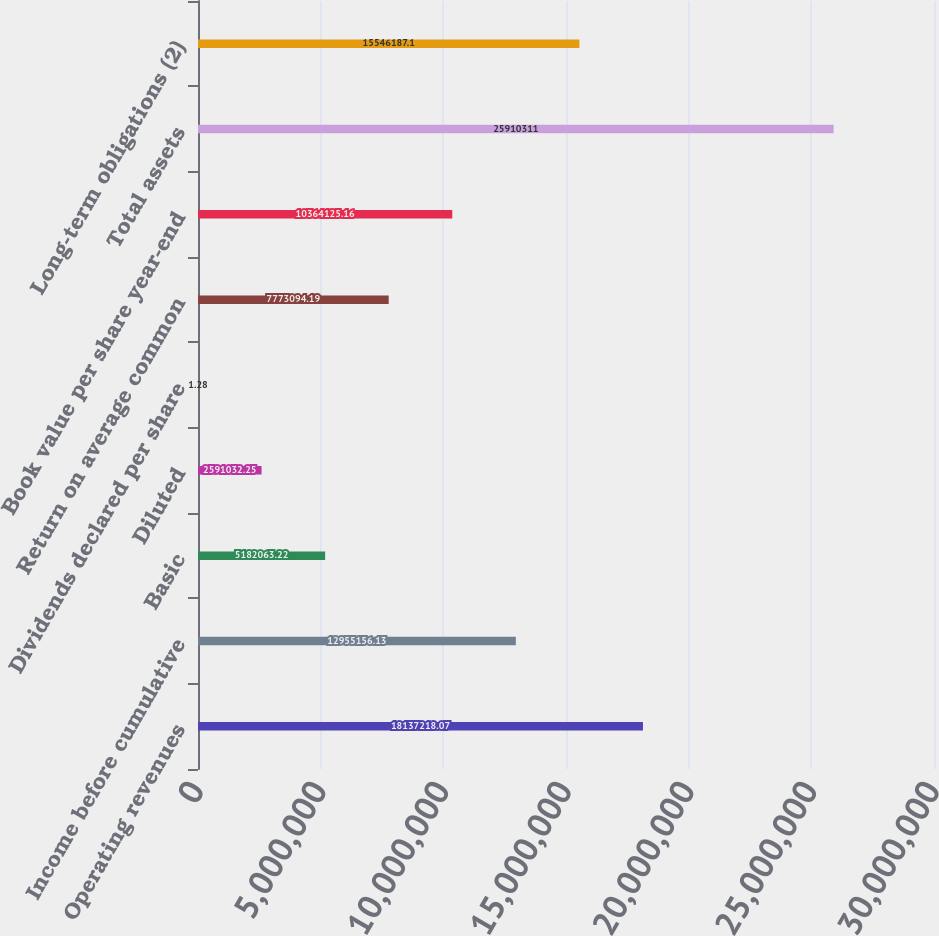Convert chart. <chart><loc_0><loc_0><loc_500><loc_500><bar_chart><fcel>Operating revenues<fcel>Income before cumulative<fcel>Basic<fcel>Diluted<fcel>Dividends declared per share<fcel>Return on average common<fcel>Book value per share year-end<fcel>Total assets<fcel>Long-term obligations (2)<nl><fcel>1.81372e+07<fcel>1.29552e+07<fcel>5.18206e+06<fcel>2.59103e+06<fcel>1.28<fcel>7.77309e+06<fcel>1.03641e+07<fcel>2.59103e+07<fcel>1.55462e+07<nl></chart> 